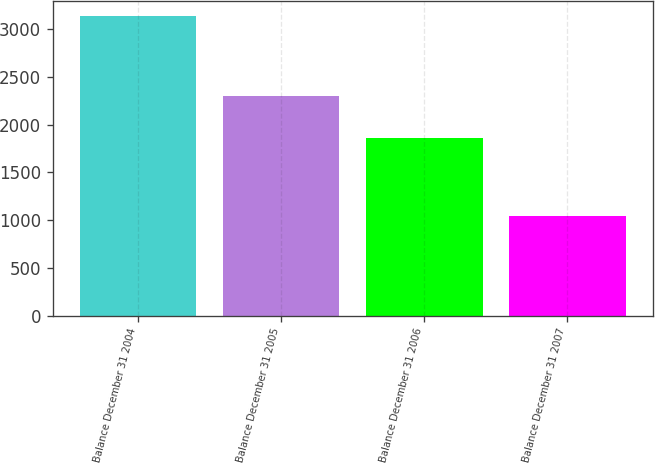Convert chart to OTSL. <chart><loc_0><loc_0><loc_500><loc_500><bar_chart><fcel>Balance December 31 2004<fcel>Balance December 31 2005<fcel>Balance December 31 2006<fcel>Balance December 31 2007<nl><fcel>3141<fcel>2302<fcel>1866<fcel>1046<nl></chart> 